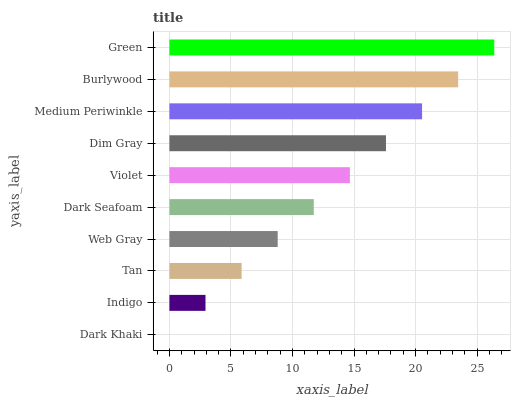Is Dark Khaki the minimum?
Answer yes or no. Yes. Is Green the maximum?
Answer yes or no. Yes. Is Indigo the minimum?
Answer yes or no. No. Is Indigo the maximum?
Answer yes or no. No. Is Indigo greater than Dark Khaki?
Answer yes or no. Yes. Is Dark Khaki less than Indigo?
Answer yes or no. Yes. Is Dark Khaki greater than Indigo?
Answer yes or no. No. Is Indigo less than Dark Khaki?
Answer yes or no. No. Is Violet the high median?
Answer yes or no. Yes. Is Dark Seafoam the low median?
Answer yes or no. Yes. Is Dark Seafoam the high median?
Answer yes or no. No. Is Dark Khaki the low median?
Answer yes or no. No. 